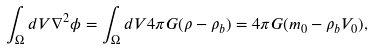<formula> <loc_0><loc_0><loc_500><loc_500>\int _ { \Omega } d V \nabla ^ { 2 } \phi = \int _ { \Omega } d V 4 \pi G ( \rho - \rho _ { b } ) = 4 \pi G ( m _ { 0 } - \rho _ { b } V _ { 0 } ) ,</formula> 